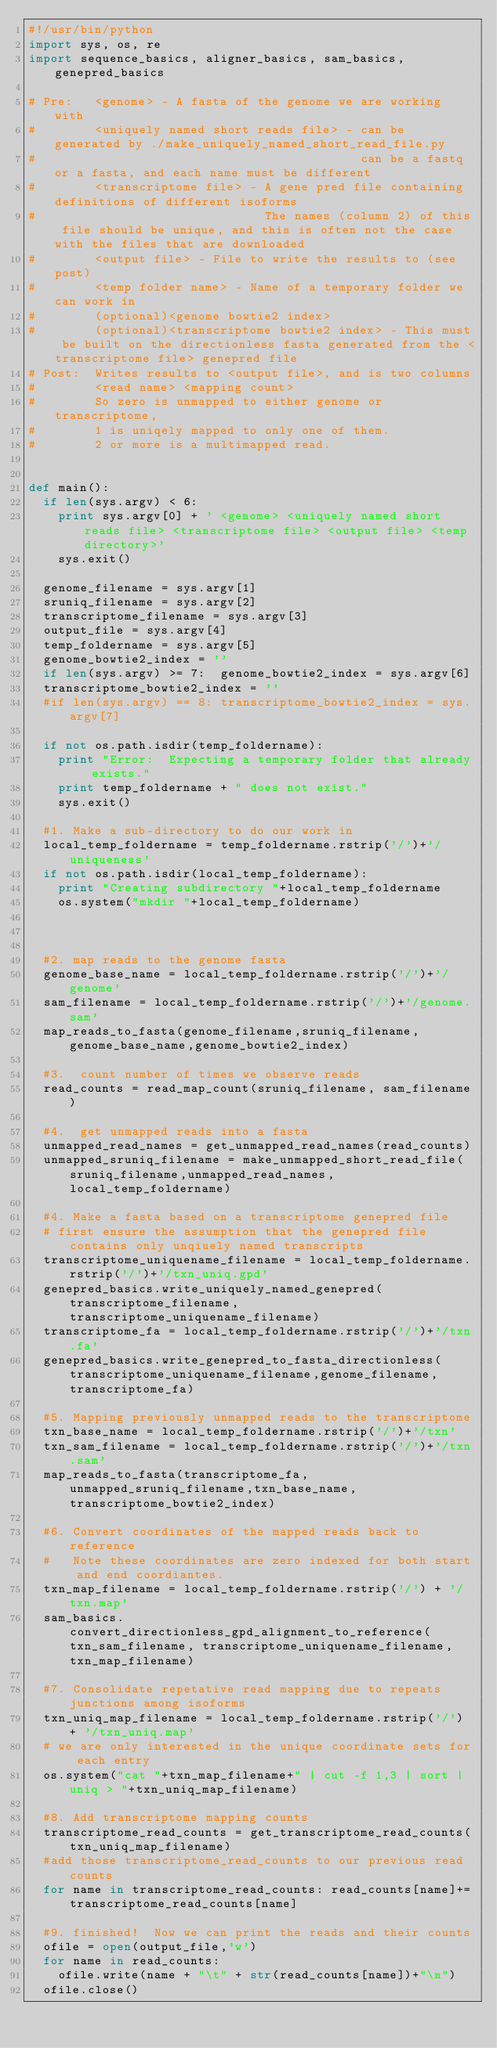<code> <loc_0><loc_0><loc_500><loc_500><_Python_>#!/usr/bin/python
import sys, os, re
import sequence_basics, aligner_basics, sam_basics, genepred_basics

# Pre:   <genome> - A fasta of the genome we are working with
#        <uniquely named short reads file> - can be generated by ./make_uniquely_named_short_read_file.py
#                                            can be a fastq or a fasta, and each name must be different
#        <transcriptome file> - A gene pred file containing definitions of different isoforms
#                               The names (column 2) of this file should be unique, and this is often not the case with the files that are downloaded
#        <output file> - File to write the results to (see post)
#        <temp folder name> - Name of a temporary folder we can work in
#        (optional)<genome bowtie2 index>
#        (optional)<transcriptome bowtie2 index> - This must be built on the directionless fasta generated from the <transcriptome file> genepred file
# Post:  Writes results to <output file>, and is two columns 
#        <read name> <mapping count>
#        So zero is unmapped to either genome or transcriptome,
#        1 is uniqely mapped to only one of them.
#        2 or more is a multimapped read.


def main():
  if len(sys.argv) < 6:
    print sys.argv[0] + ' <genome> <uniquely named short reads file> <transcriptome file> <output file> <temp directory>'
    sys.exit()

  genome_filename = sys.argv[1]
  sruniq_filename = sys.argv[2]
  transcriptome_filename = sys.argv[3]
  output_file = sys.argv[4]
  temp_foldername = sys.argv[5]
  genome_bowtie2_index = ''
  if len(sys.argv) >= 7:  genome_bowtie2_index = sys.argv[6]
  transcriptome_bowtie2_index = ''
  #if len(sys.argv) == 8: transcriptome_bowtie2_index = sys.argv[7]

  if not os.path.isdir(temp_foldername):
    print "Error:  Expecting a temporary folder that already exists."
    print temp_foldername + " does not exist."
    sys.exit()

  #1. Make a sub-directory to do our work in
  local_temp_foldername = temp_foldername.rstrip('/')+'/uniqueness'
  if not os.path.isdir(local_temp_foldername):
    print "Creating subdirectory "+local_temp_foldername
    os.system("mkdir "+local_temp_foldername)



  #2. map reads to the genome fasta
  genome_base_name = local_temp_foldername.rstrip('/')+'/genome'
  sam_filename = local_temp_foldername.rstrip('/')+'/genome.sam'
  map_reads_to_fasta(genome_filename,sruniq_filename,genome_base_name,genome_bowtie2_index)
  
  #3.  count number of times we observe reads 
  read_counts = read_map_count(sruniq_filename, sam_filename)

  #4.  get unmapped reads into a fasta
  unmapped_read_names = get_unmapped_read_names(read_counts)
  unmapped_sruniq_filename = make_unmapped_short_read_file(sruniq_filename,unmapped_read_names,local_temp_foldername)

  #4. Make a fasta based on a transcriptome genepred file
  # first ensure the assumption that the genepred file contains only unqiuely named transcripts
  transcriptome_uniquename_filename = local_temp_foldername.rstrip('/')+'/txn_uniq.gpd'  
  genepred_basics.write_uniquely_named_genepred(transcriptome_filename,transcriptome_uniquename_filename)
  transcriptome_fa = local_temp_foldername.rstrip('/')+'/txn.fa'
  genepred_basics.write_genepred_to_fasta_directionless(transcriptome_uniquename_filename,genome_filename,transcriptome_fa)

  #5. Mapping previously unmapped reads to the transcriptome
  txn_base_name = local_temp_foldername.rstrip('/')+'/txn'
  txn_sam_filename = local_temp_foldername.rstrip('/')+'/txn.sam'
  map_reads_to_fasta(transcriptome_fa,unmapped_sruniq_filename,txn_base_name,transcriptome_bowtie2_index)
  
  #6. Convert coordinates of the mapped reads back to reference
  #   Note these coordinates are zero indexed for both start and end coordiantes.
  txn_map_filename = local_temp_foldername.rstrip('/') + '/txn.map'
  sam_basics.convert_directionless_gpd_alignment_to_reference(txn_sam_filename, transcriptome_uniquename_filename,txn_map_filename)
  
  #7. Consolidate repetative read mapping due to repeats junctions among isoforms
  txn_uniq_map_filename = local_temp_foldername.rstrip('/') + '/txn_uniq.map'
  # we are only interested in the unique coordinate sets for each entry
  os.system("cat "+txn_map_filename+" | cut -f 1,3 | sort | uniq > "+txn_uniq_map_filename)

  #8. Add transcriptome mapping counts
  transcriptome_read_counts = get_transcriptome_read_counts(txn_uniq_map_filename)
  #add those transcriptome_read_counts to our previous read counts
  for name in transcriptome_read_counts: read_counts[name]+=transcriptome_read_counts[name]

  #9. finished!  Now we can print the reads and their counts
  ofile = open(output_file,'w')
  for name in read_counts:
    ofile.write(name + "\t" + str(read_counts[name])+"\n")
  ofile.close()
</code> 